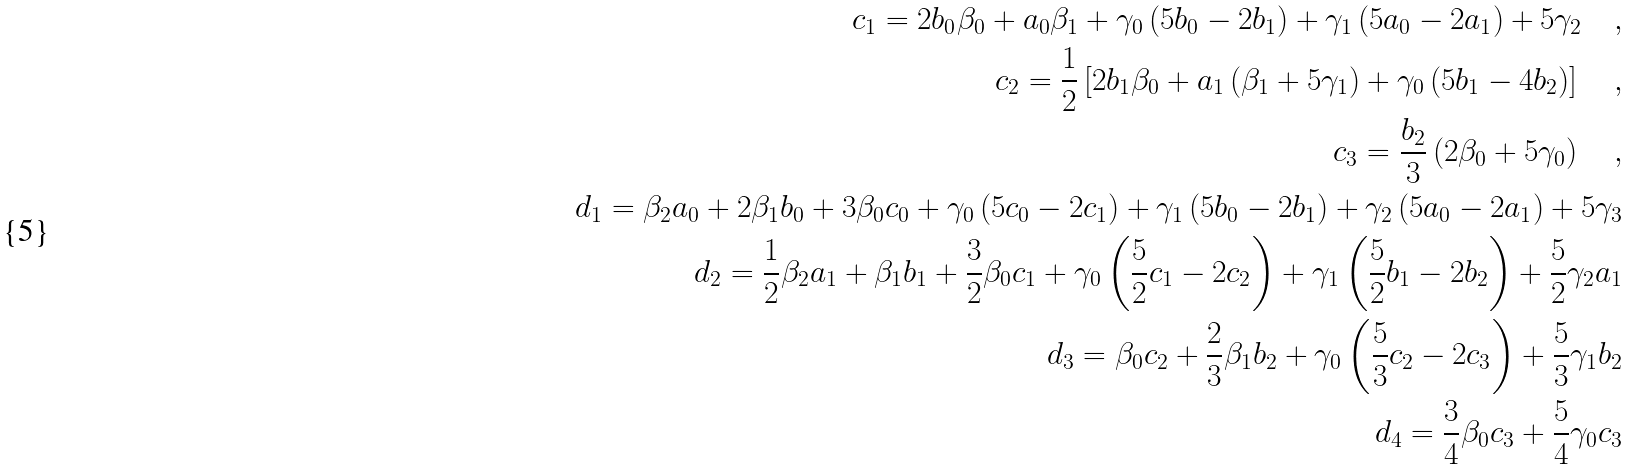<formula> <loc_0><loc_0><loc_500><loc_500>c _ { 1 } = 2 b _ { 0 } \beta _ { 0 } + a _ { 0 } \beta _ { 1 } + \gamma _ { 0 } \left ( 5 b _ { 0 } - 2 b _ { 1 } \right ) + \gamma _ { 1 } \left ( 5 a _ { 0 } - 2 a _ { 1 } \right ) + 5 \gamma _ { 2 } \quad , \\ c _ { 2 } = \frac { 1 } { 2 } \left [ 2 b _ { 1 } \beta _ { 0 } + a _ { 1 } \left ( \beta _ { 1 } + 5 \gamma _ { 1 } \right ) + \gamma _ { 0 } \left ( 5 b _ { 1 } - 4 b _ { 2 } \right ) \right ] \quad , \\ c _ { 3 } = \frac { b _ { 2 } } { 3 } \left ( 2 \beta _ { 0 } + 5 \gamma _ { 0 } \right ) \quad , \\ d _ { 1 } = \beta _ { 2 } a _ { 0 } + 2 \beta _ { 1 } b _ { 0 } + 3 \beta _ { 0 } c _ { 0 } + \gamma _ { 0 } \left ( 5 c _ { 0 } - 2 c _ { 1 } \right ) + \gamma _ { 1 } \left ( 5 b _ { 0 } - 2 b _ { 1 } \right ) + \gamma _ { 2 } \left ( 5 a _ { 0 } - 2 a _ { 1 } \right ) + 5 \gamma _ { 3 } \\ d _ { 2 } = \frac { 1 } { 2 } \beta _ { 2 } a _ { 1 } + \beta _ { 1 } b _ { 1 } + \frac { 3 } { 2 } \beta _ { 0 } c _ { 1 } + \gamma _ { 0 } \left ( \frac { 5 } { 2 } c _ { 1 } - 2 c _ { 2 } \right ) + \gamma _ { 1 } \left ( \frac { 5 } { 2 } b _ { 1 } - 2 b _ { 2 } \right ) + \frac { 5 } { 2 } \gamma _ { 2 } a _ { 1 } \\ d _ { 3 } = \beta _ { 0 } c _ { 2 } + \frac { 2 } { 3 } \beta _ { 1 } b _ { 2 } + \gamma _ { 0 } \left ( \frac { 5 } { 3 } c _ { 2 } - 2 c _ { 3 } \right ) + \frac { 5 } { 3 } \gamma _ { 1 } b _ { 2 } \\ d _ { 4 } = \frac { 3 } { 4 } \beta _ { 0 } c _ { 3 } + \frac { 5 } { 4 } \gamma _ { 0 } c _ { 3 }</formula> 